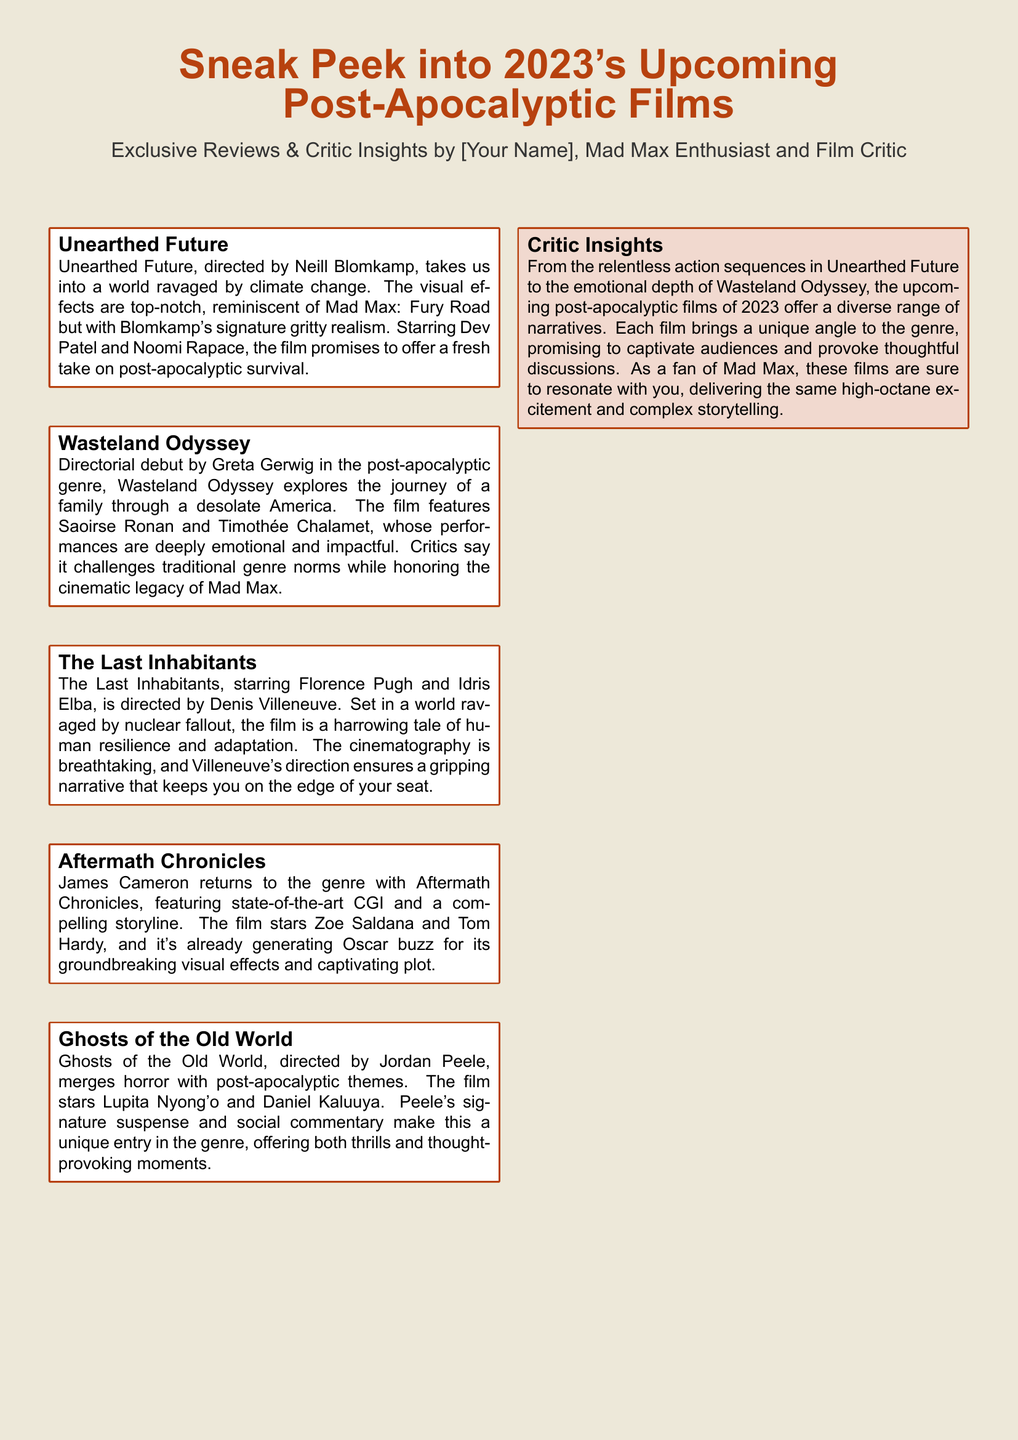What is the title of the film directed by Neill Blomkamp? The document lists "Unearthed Future" as the film directed by Neill Blomkamp.
Answer: Unearthed Future Who stars in "Wasteland Odyssey"? The film "Wasteland Odyssey" features Saoirse Ronan and Timothée Chalamet.
Answer: Saoirse Ronan and Timothée Chalamet What genre does "Ghosts of the Old World" merge with post-apocalyptic themes? The film "Ghosts of the Old World" merges horror with post-apocalyptic themes.
Answer: Horror Which film is directed by Greta Gerwig? The document indicates that Greta Gerwig directs "Wasteland Odyssey."
Answer: Wasteland Odyssey How many films are highlighted in the document? The document presents five upcoming post-apocalyptic films.
Answer: Five Who is the director of "The Last Inhabitants"? "The Last Inhabitants" is directed by Denis Villeneuve, as stated in the document.
Answer: Denis Villeneuve What common element do all the upcoming films share according to the Critic Insights? The Critic Insights suggest that the films all offer diverse narratives within the post-apocalyptic genre.
Answer: Diverse narratives What famous franchise is mentioned in connection with the emotional depth of "Wasteland Odyssey"? The document references the cinematic legacy of "Mad Max" in relation to "Wasteland Odyssey."
Answer: Mad Max Which actor is part of the cast in "Aftermath Chronicles"? According to the document, Zoe Saldana is one of the stars of "Aftermath Chronicles."
Answer: Zoe Saldana 